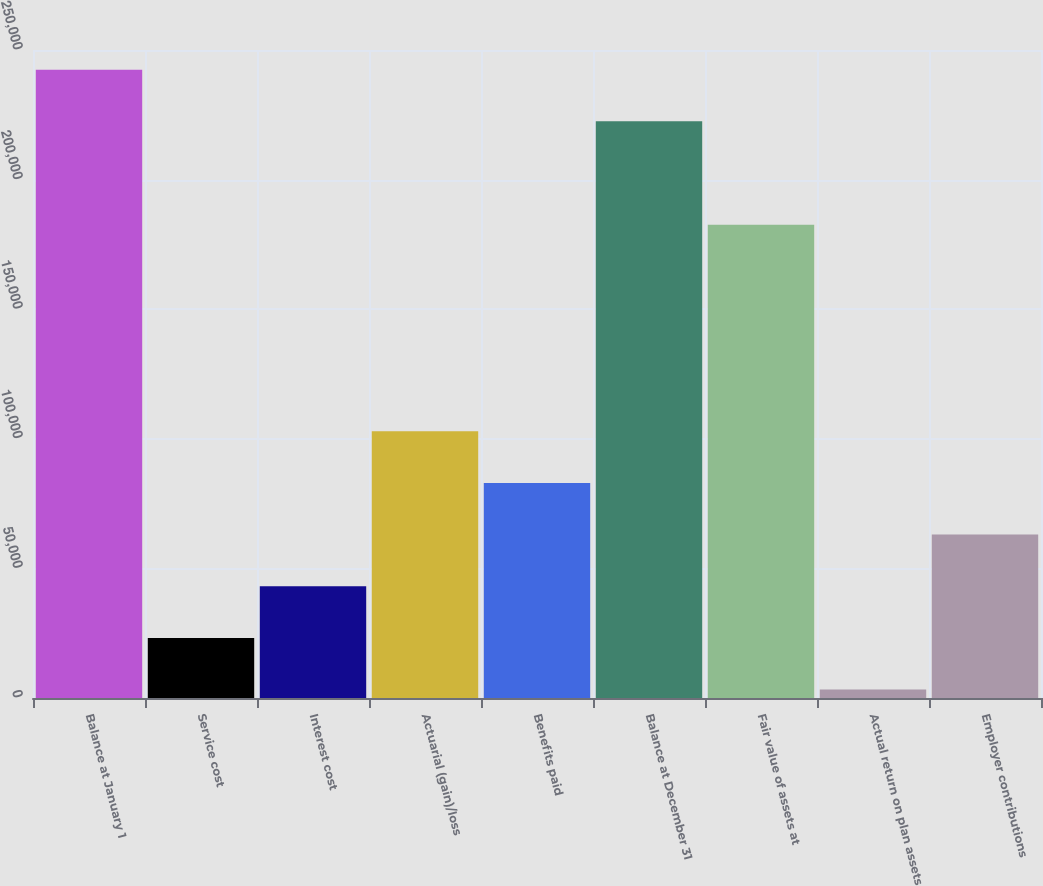<chart> <loc_0><loc_0><loc_500><loc_500><bar_chart><fcel>Balance at January 1<fcel>Service cost<fcel>Interest cost<fcel>Actuarial (gain)/loss<fcel>Benefits paid<fcel>Balance at December 31<fcel>Fair value of assets at<fcel>Actual return on plan assets<fcel>Employer contributions<nl><fcel>242417<fcel>23174.2<fcel>43105.4<fcel>102899<fcel>82967.8<fcel>222486<fcel>182624<fcel>3243<fcel>63036.6<nl></chart> 